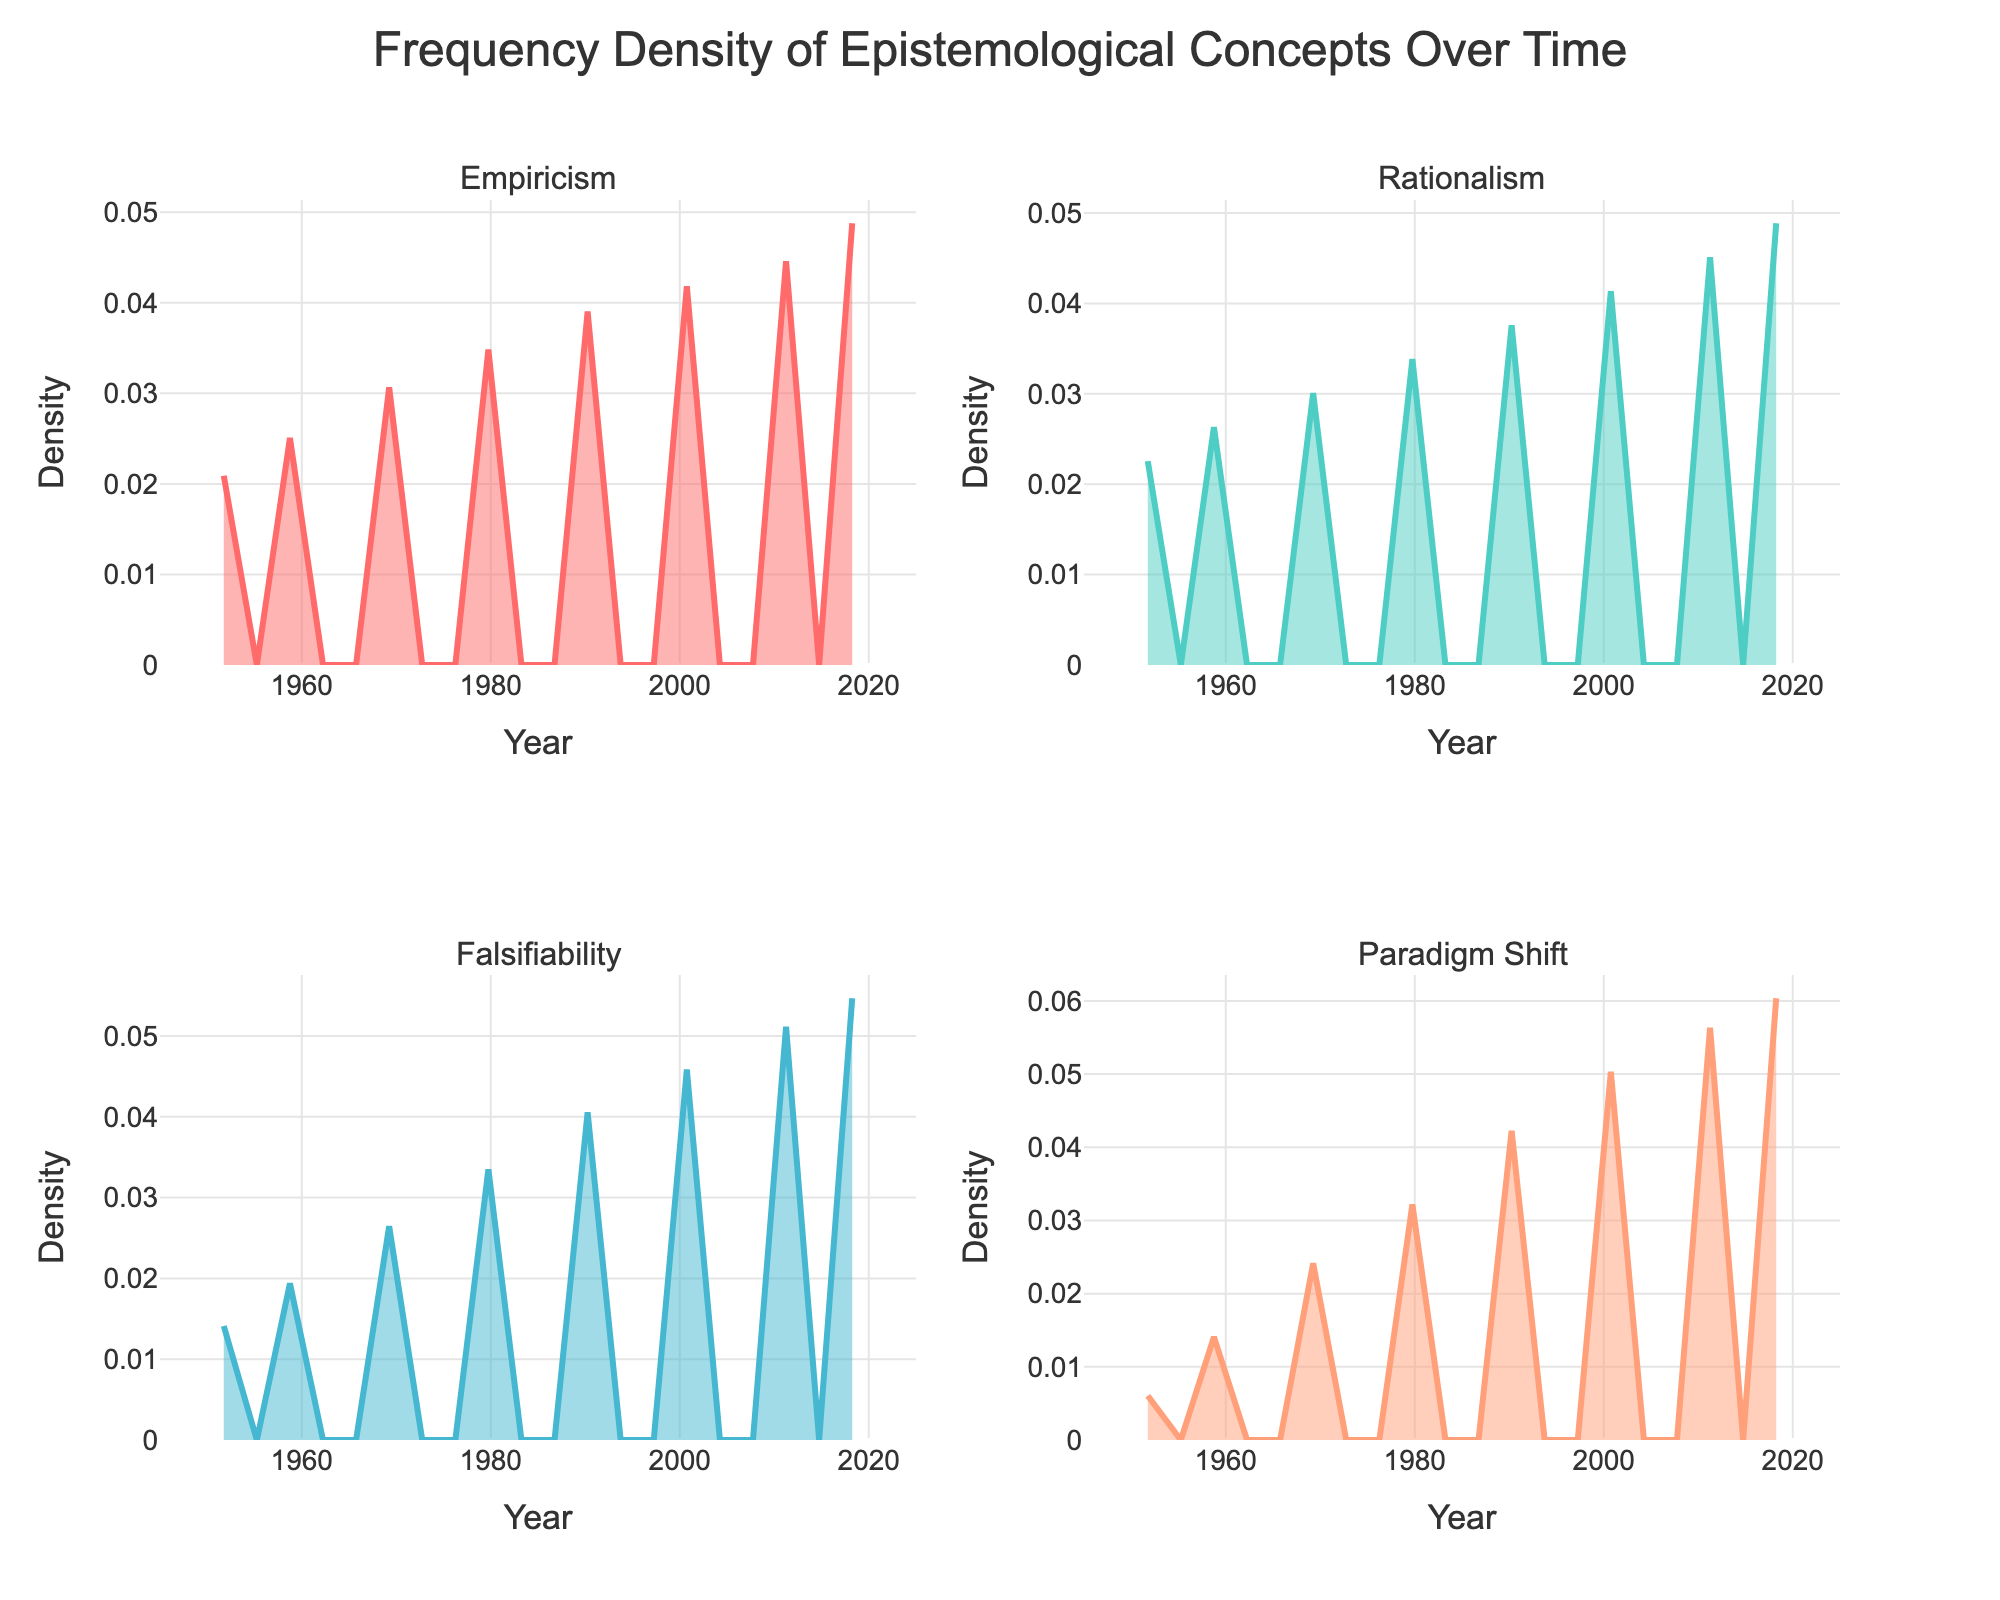what is the title of the figure? The title of the figure is located at the top center. It reads "Frequency Density of Epistemological Concepts Over Time".
Answer: Frequency Density of Epistemological Concepts Over Time Are all subplots measuring the same y-axis variable? Since each subplot measures the density (frequency) of a specific concept over time, all subplots have the y-axis titled "Density". This indicates they are all measuring the same y-axis variable.
Answer: Yes Which concept shows the highest density value in the year 2020? To find the highest density value for each concept in a given year, we need to inspect the plots and compare the y-axis values. From visual inspection, "Empiricism" has the highest density value in 2020 compared to the other concepts.
Answer: Empiricism Between the years 1980 and 2020, which concept experienced the greatest growth in density? By examining the change in density from 1980 to 2020 for each concept, we see that "Falsifiability" shows a substantial increase in density, indicating it experienced the greatest growth compared to the other concepts.
Answer: Falsifiability What is the approximate density value for Rationalism in 1970? Observing the Rationalism subplot, the density value in the year 1970 hovers around a specific point on the y-axis. From visual estimation, the density value is approximately 0.0006.
Answer: 0.0006 How does the trend in Paradigm Shift compare to the trend in Empiricism over time? When comparing the trends in their respective subplots, we notice Paradigm Shift begins with a lower density and shows an incremental increase, whereas Empiricism starts with a higher density and increases steadily throughout the timeline. Both concepts grow, but Empiricism shows higher overall density.
Answer: Paradigm Shift starts lower, both increase, Empiricism is higher overall From the subplots, which concept appears to have a steady increase without any drastic peaks or drops? Visual analysis reveals that "Empiricism" has a steady and consistent upward slope, indicating a sustained increase in density over time without drastic fluctuations.
Answer: Empiricism What pattern do you observe in the frequency density of Rationalism from 1950 to 2020? Observing the Rationalism subplot, the density increases smoothly over the years from 1950 to 2020. There are no abrupt changes or spikes, just a steady rise in density.
Answer: Steady increase Which concept has the lowest density in the 1950s? By comparing the initial density values in each subplot, the "Paradigm Shift" concept has the lowest density value in the 1950s.
Answer: Paradigm Shift Based on the density patterns, which two concepts are the most closely related in their trends? By comparing the density trends in the subplots, "Rationalism" and "Falsifiability" show the most closely correlated patterns with steady increases over the years, while maintaining similar density shapes.
Answer: Rationalism and Falsifiability 